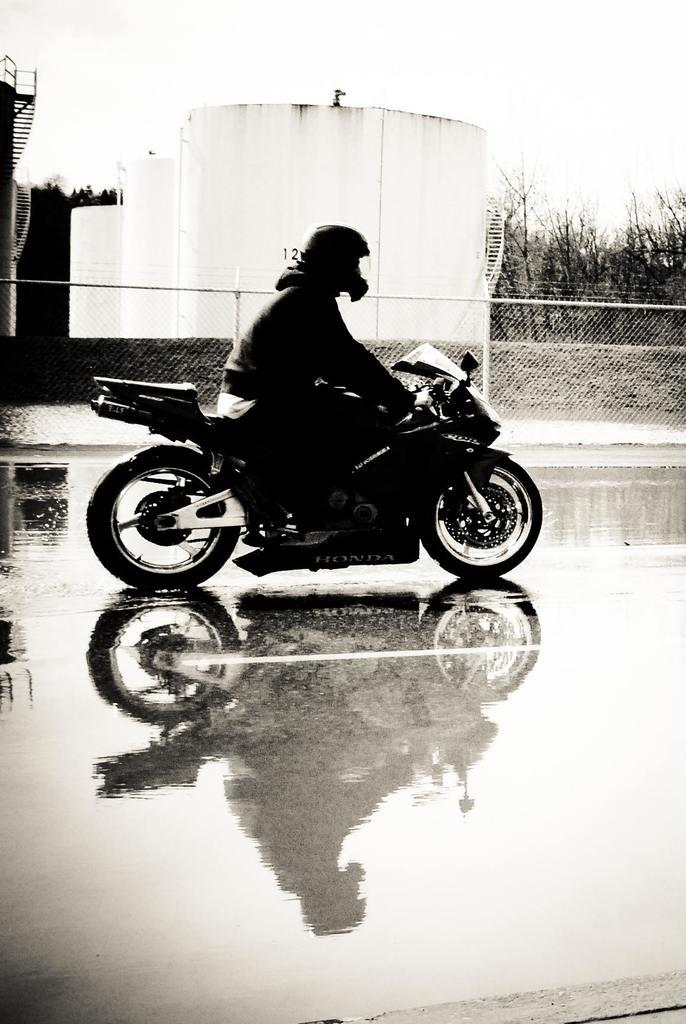What is the man in the image doing? The man is riding a motorcycle in the image. What safety precaution is the man taking while riding the motorcycle? The man is wearing a helmet. What can be seen in the background of the image? There are tanks, trees, and a fence in the background of the image. What is visible at the bottom of the image? There is water visible at the bottom of the image. What type of game is the man playing in the image? There is no game being played in the image; the man is riding a motorcycle. What does the man need to start the motorcycle in the image? The image does not show the man starting the motorcycle, so it is not possible to determine what he might need. 